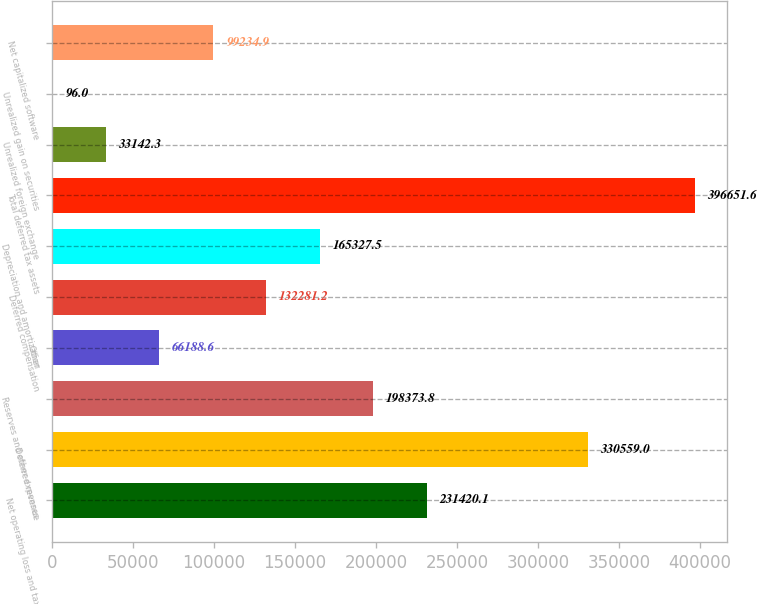<chart> <loc_0><loc_0><loc_500><loc_500><bar_chart><fcel>Net operating loss and tax<fcel>Deferred revenue<fcel>Reserves and other expenses<fcel>Other<fcel>Deferred compensation<fcel>Depreciation and amortization<fcel>Total deferred tax assets<fcel>Unrealized foreign exchange<fcel>Unrealized gain on securities<fcel>Net capitalized software<nl><fcel>231420<fcel>330559<fcel>198374<fcel>66188.6<fcel>132281<fcel>165328<fcel>396652<fcel>33142.3<fcel>96<fcel>99234.9<nl></chart> 